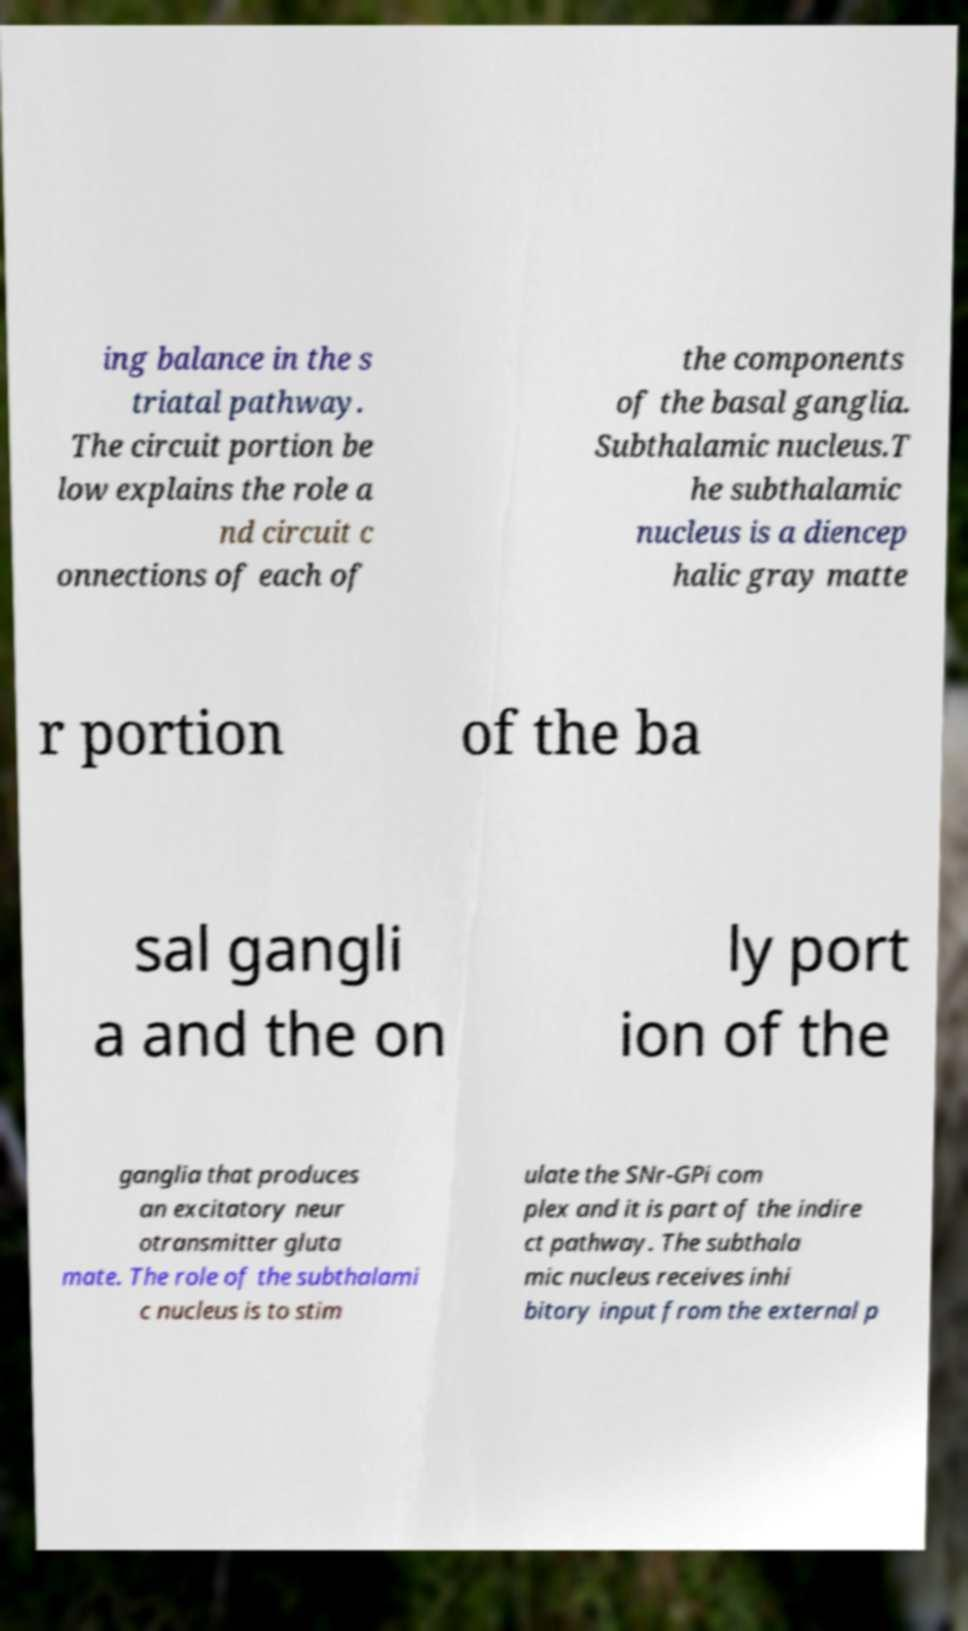Could you extract and type out the text from this image? ing balance in the s triatal pathway. The circuit portion be low explains the role a nd circuit c onnections of each of the components of the basal ganglia. Subthalamic nucleus.T he subthalamic nucleus is a diencep halic gray matte r portion of the ba sal gangli a and the on ly port ion of the ganglia that produces an excitatory neur otransmitter gluta mate. The role of the subthalami c nucleus is to stim ulate the SNr-GPi com plex and it is part of the indire ct pathway. The subthala mic nucleus receives inhi bitory input from the external p 